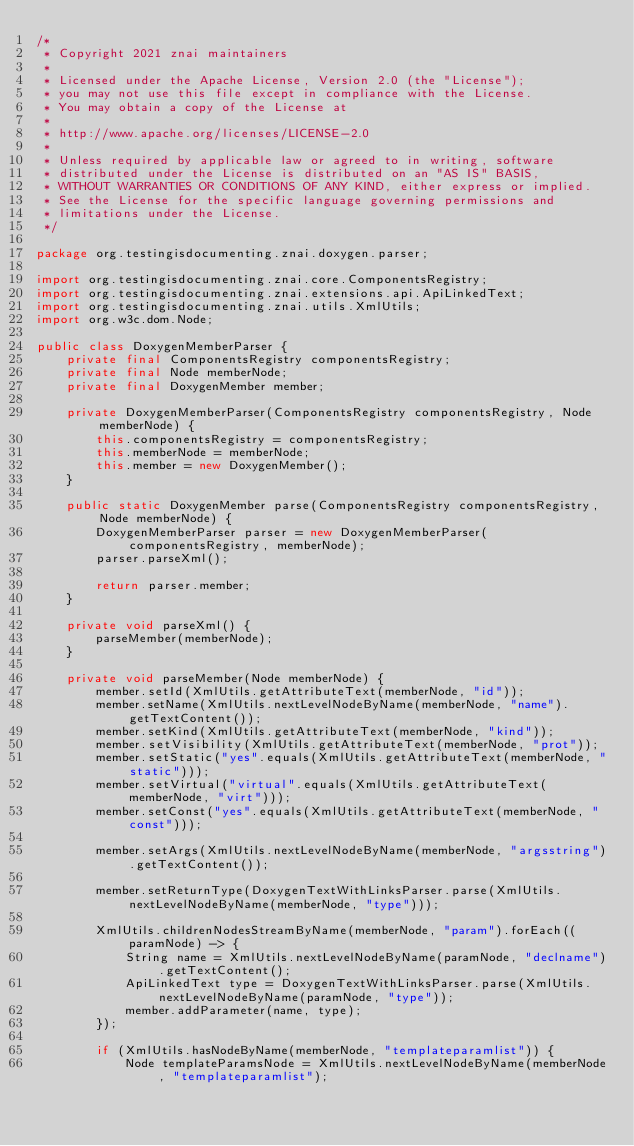Convert code to text. <code><loc_0><loc_0><loc_500><loc_500><_Java_>/*
 * Copyright 2021 znai maintainers
 *
 * Licensed under the Apache License, Version 2.0 (the "License");
 * you may not use this file except in compliance with the License.
 * You may obtain a copy of the License at
 *
 * http://www.apache.org/licenses/LICENSE-2.0
 *
 * Unless required by applicable law or agreed to in writing, software
 * distributed under the License is distributed on an "AS IS" BASIS,
 * WITHOUT WARRANTIES OR CONDITIONS OF ANY KIND, either express or implied.
 * See the License for the specific language governing permissions and
 * limitations under the License.
 */

package org.testingisdocumenting.znai.doxygen.parser;

import org.testingisdocumenting.znai.core.ComponentsRegistry;
import org.testingisdocumenting.znai.extensions.api.ApiLinkedText;
import org.testingisdocumenting.znai.utils.XmlUtils;
import org.w3c.dom.Node;

public class DoxygenMemberParser {
    private final ComponentsRegistry componentsRegistry;
    private final Node memberNode;
    private final DoxygenMember member;

    private DoxygenMemberParser(ComponentsRegistry componentsRegistry, Node memberNode) {
        this.componentsRegistry = componentsRegistry;
        this.memberNode = memberNode;
        this.member = new DoxygenMember();
    }

    public static DoxygenMember parse(ComponentsRegistry componentsRegistry, Node memberNode) {
        DoxygenMemberParser parser = new DoxygenMemberParser(componentsRegistry, memberNode);
        parser.parseXml();

        return parser.member;
    }

    private void parseXml() {
        parseMember(memberNode);
    }

    private void parseMember(Node memberNode) {
        member.setId(XmlUtils.getAttributeText(memberNode, "id"));
        member.setName(XmlUtils.nextLevelNodeByName(memberNode, "name").getTextContent());
        member.setKind(XmlUtils.getAttributeText(memberNode, "kind"));
        member.setVisibility(XmlUtils.getAttributeText(memberNode, "prot"));
        member.setStatic("yes".equals(XmlUtils.getAttributeText(memberNode, "static")));
        member.setVirtual("virtual".equals(XmlUtils.getAttributeText(memberNode, "virt")));
        member.setConst("yes".equals(XmlUtils.getAttributeText(memberNode, "const")));

        member.setArgs(XmlUtils.nextLevelNodeByName(memberNode, "argsstring").getTextContent());

        member.setReturnType(DoxygenTextWithLinksParser.parse(XmlUtils.nextLevelNodeByName(memberNode, "type")));

        XmlUtils.childrenNodesStreamByName(memberNode, "param").forEach((paramNode) -> {
            String name = XmlUtils.nextLevelNodeByName(paramNode, "declname").getTextContent();
            ApiLinkedText type = DoxygenTextWithLinksParser.parse(XmlUtils.nextLevelNodeByName(paramNode, "type"));
            member.addParameter(name, type);
        });

        if (XmlUtils.hasNodeByName(memberNode, "templateparamlist")) {
            Node templateParamsNode = XmlUtils.nextLevelNodeByName(memberNode, "templateparamlist");
</code> 